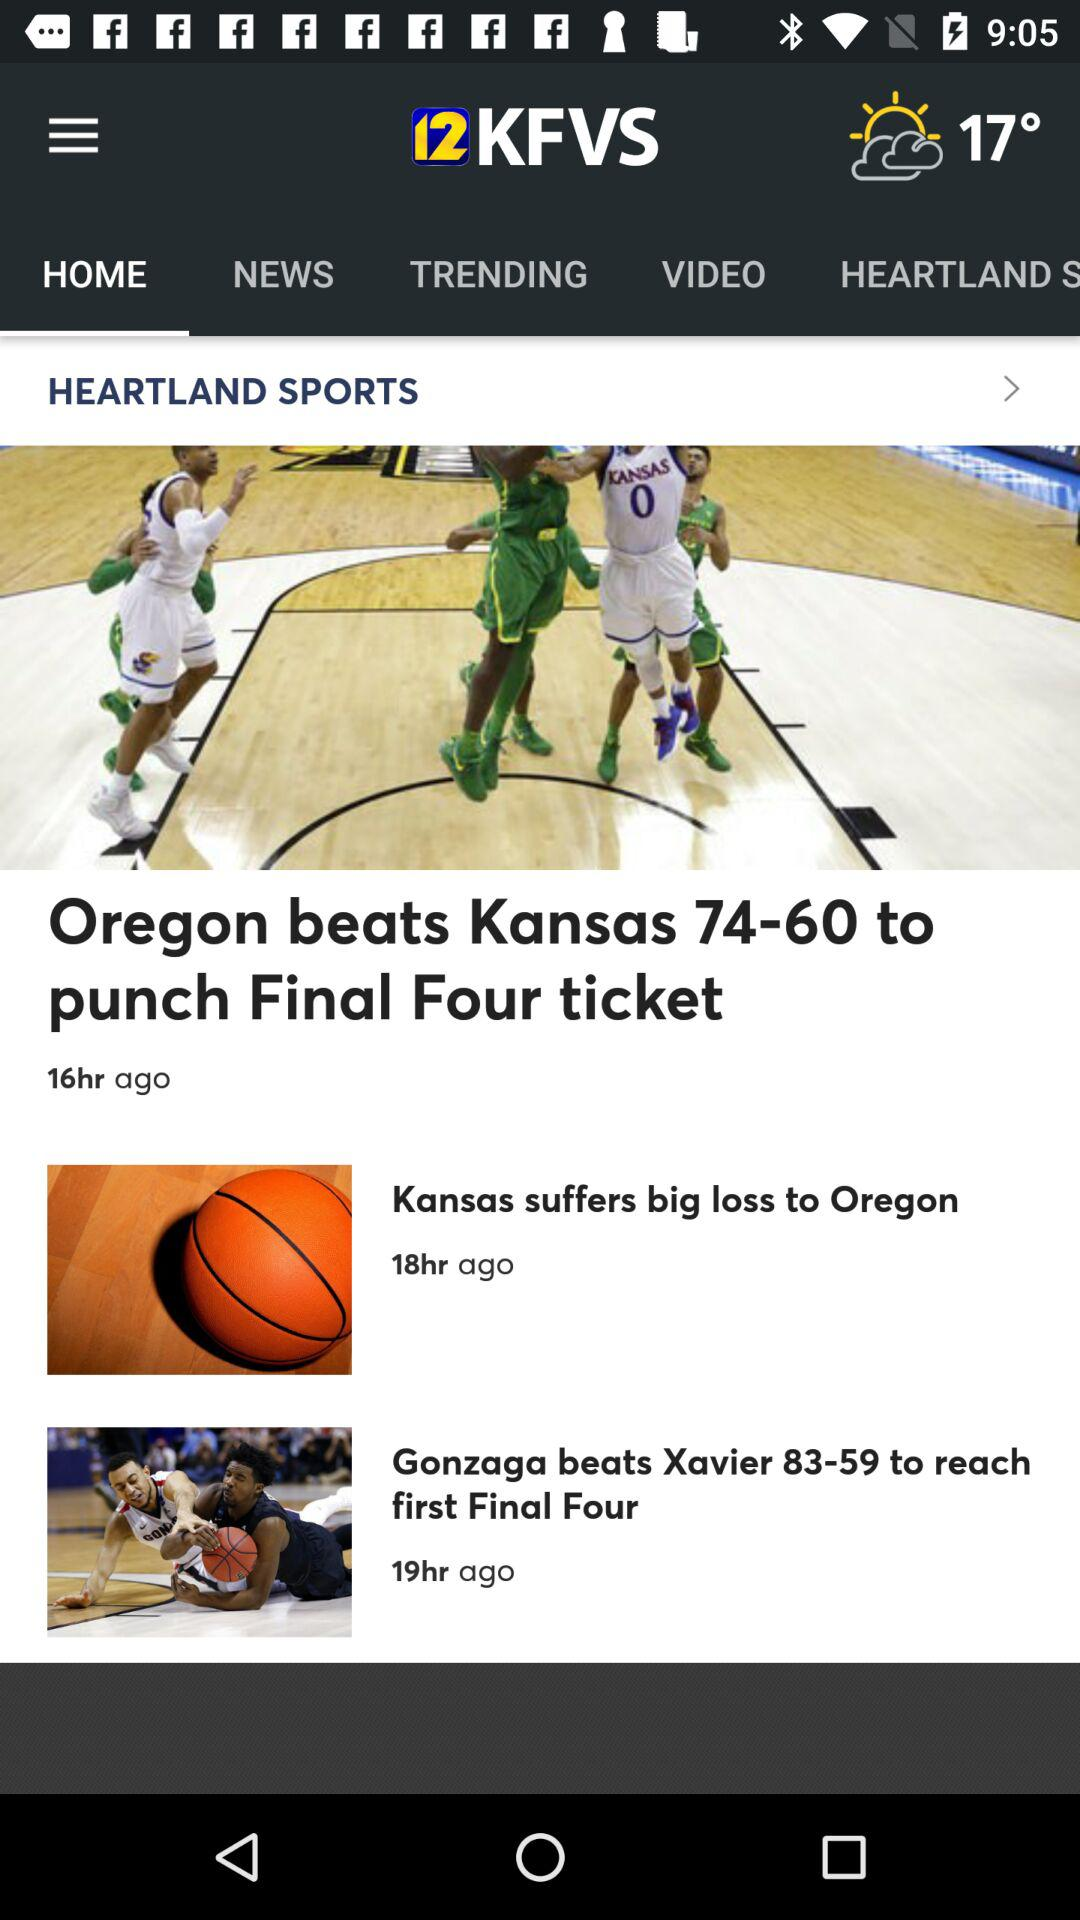What's the temperature? The temperature is 17°. 